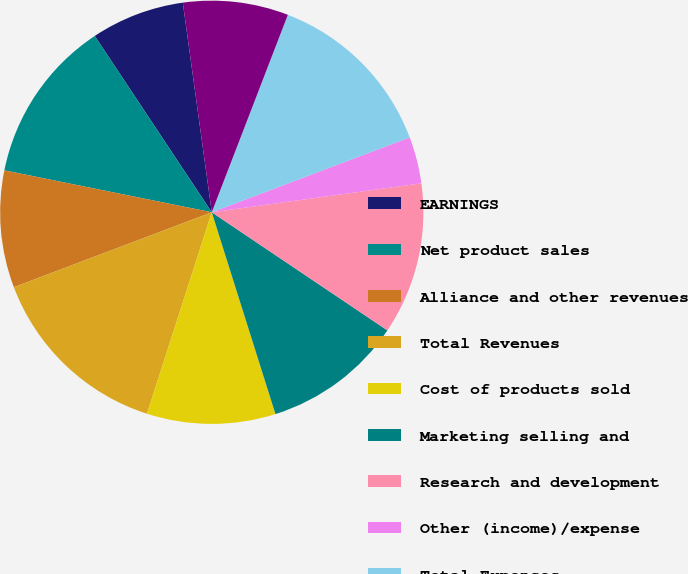Convert chart to OTSL. <chart><loc_0><loc_0><loc_500><loc_500><pie_chart><fcel>EARNINGS<fcel>Net product sales<fcel>Alliance and other revenues<fcel>Total Revenues<fcel>Cost of products sold<fcel>Marketing selling and<fcel>Research and development<fcel>Other (income)/expense<fcel>Total Expenses<fcel>Earnings Before Income Taxes<nl><fcel>7.14%<fcel>12.5%<fcel>8.93%<fcel>14.29%<fcel>9.82%<fcel>10.71%<fcel>11.61%<fcel>3.57%<fcel>13.39%<fcel>8.04%<nl></chart> 